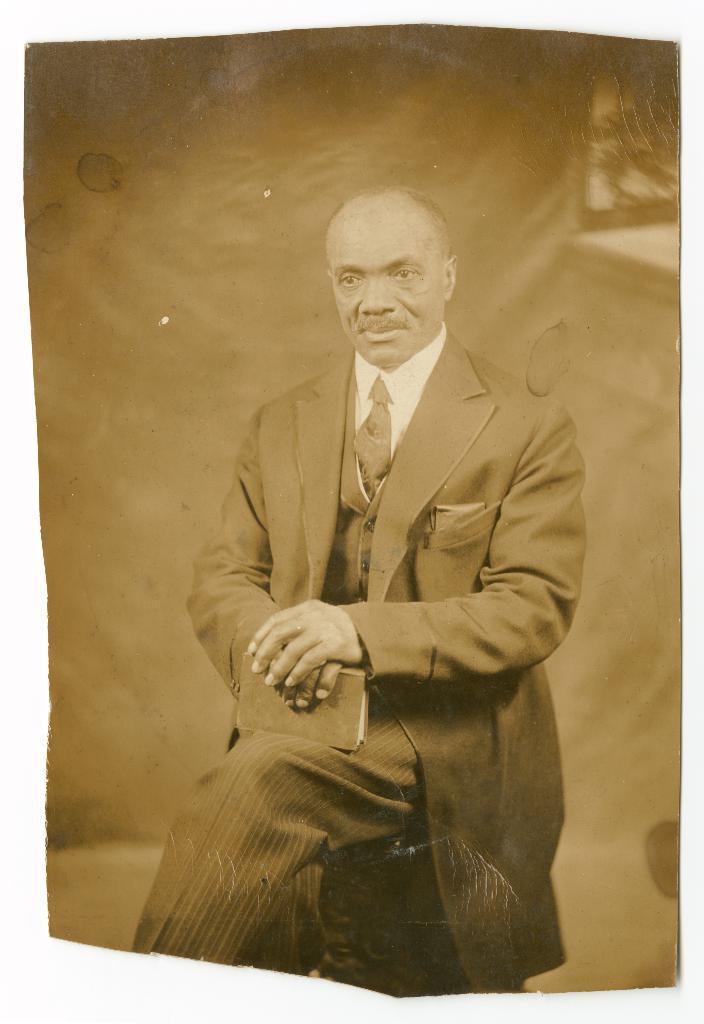How would you summarize this image in a sentence or two? In this image we can see a photo of a person holding a book and he is sitting. 